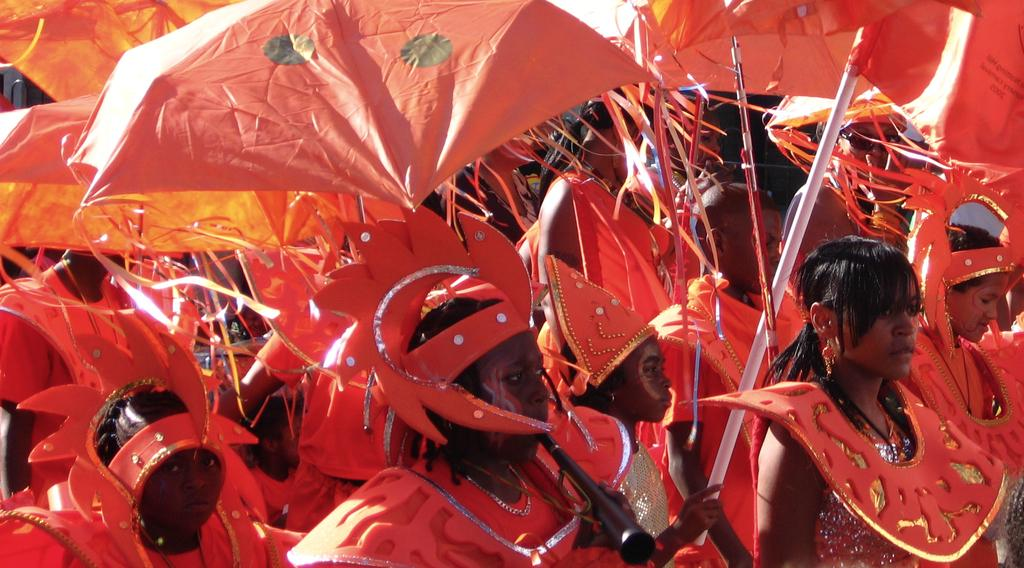What is the main subject of the image? The main subject of the image is a group of people. What are the people wearing in the image? The people are wearing red color costumes. What objects are the people holding in the image? The people are holding umbrellas and sticks. What additional accessories are the people wearing in the image? The people are wearing decorative items. What type of hose can be seen in the image? There is no hose present in the image. Can you describe the dog that is accompanying the group of people in the image? There is no dog present in the image; the group of people is the main subject. 